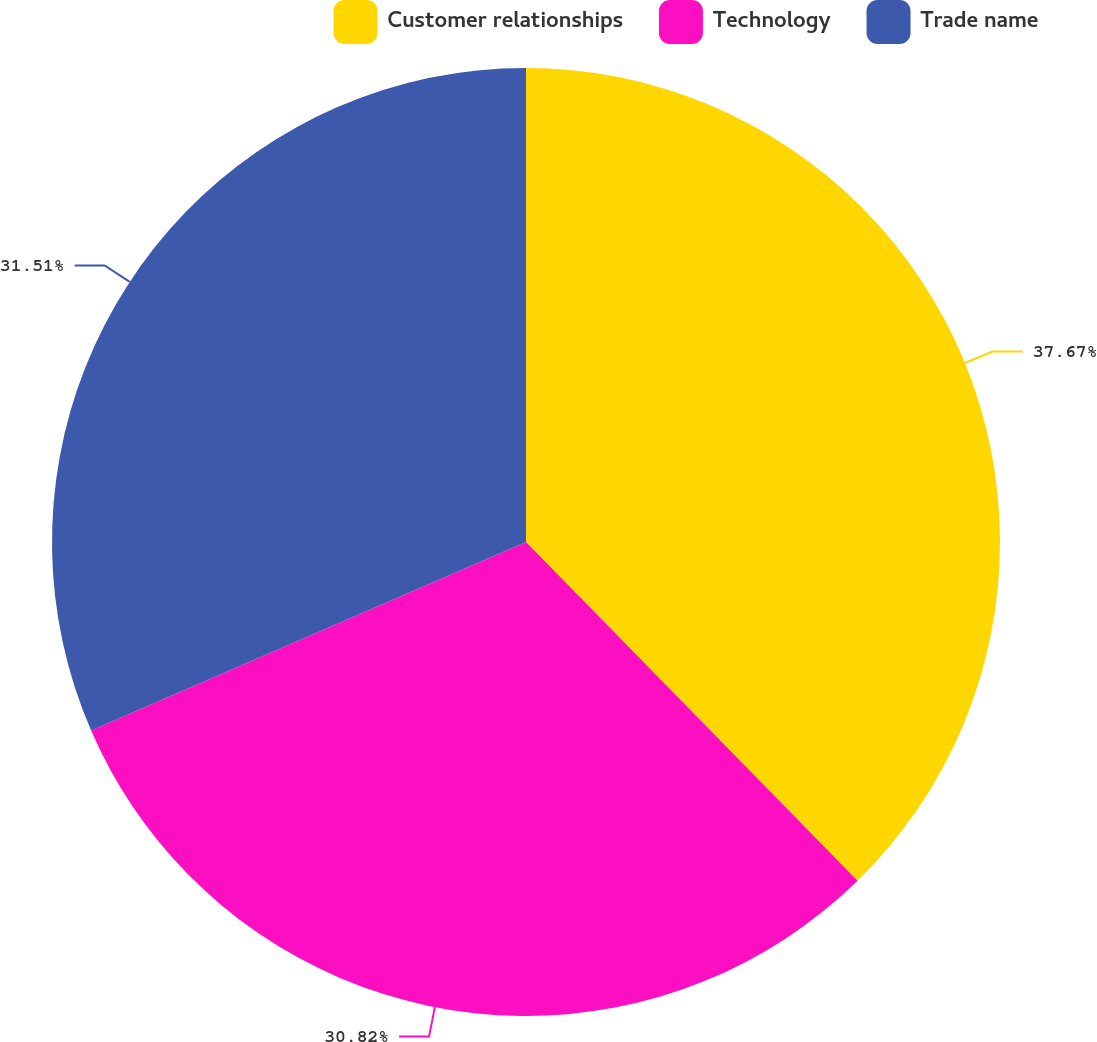<chart> <loc_0><loc_0><loc_500><loc_500><pie_chart><fcel>Customer relationships<fcel>Technology<fcel>Trade name<nl><fcel>37.67%<fcel>30.82%<fcel>31.51%<nl></chart> 